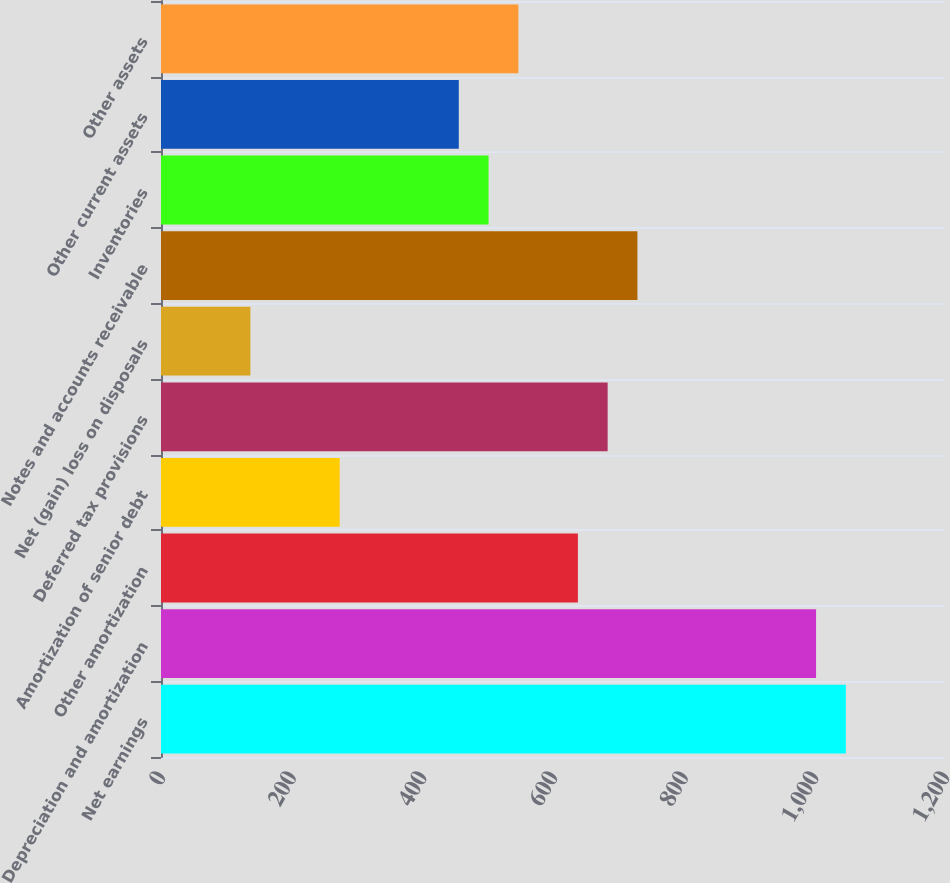Convert chart. <chart><loc_0><loc_0><loc_500><loc_500><bar_chart><fcel>Net earnings<fcel>Depreciation and amortization<fcel>Other amortization<fcel>Amortization of senior debt<fcel>Deferred tax provisions<fcel>Net (gain) loss on disposals<fcel>Notes and accounts receivable<fcel>Inventories<fcel>Other current assets<fcel>Other assets<nl><fcel>1048.21<fcel>1002.64<fcel>638.08<fcel>273.52<fcel>683.65<fcel>136.81<fcel>729.22<fcel>501.37<fcel>455.8<fcel>546.94<nl></chart> 